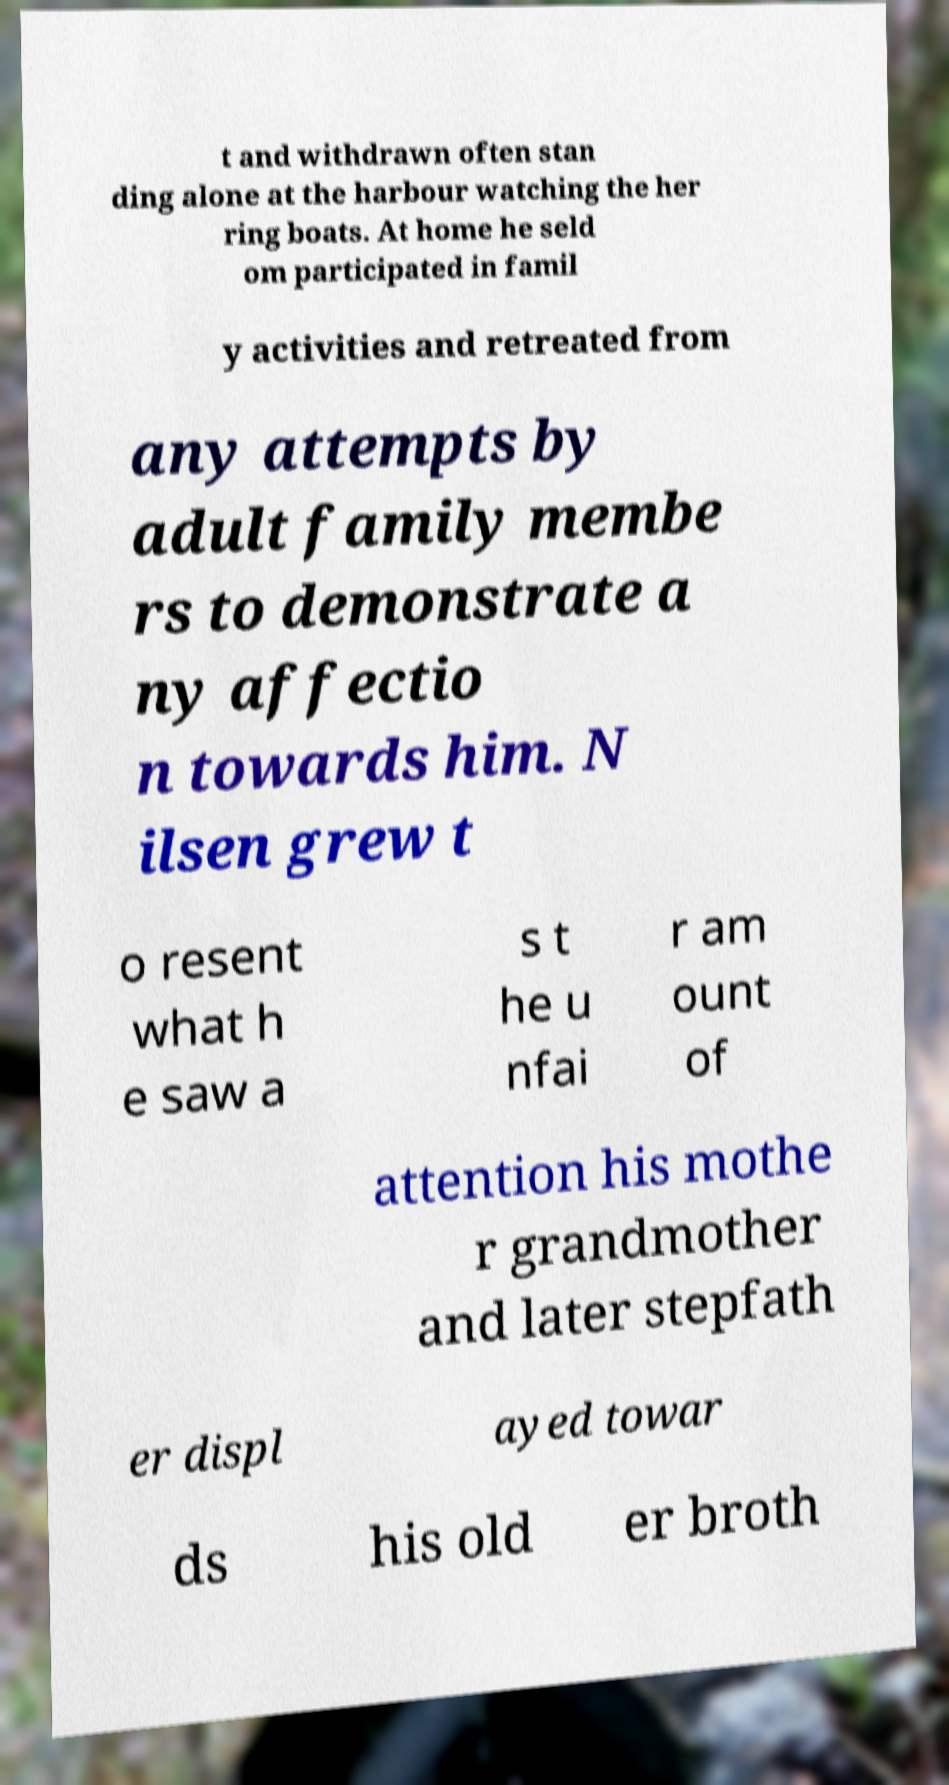Can you accurately transcribe the text from the provided image for me? t and withdrawn often stan ding alone at the harbour watching the her ring boats. At home he seld om participated in famil y activities and retreated from any attempts by adult family membe rs to demonstrate a ny affectio n towards him. N ilsen grew t o resent what h e saw a s t he u nfai r am ount of attention his mothe r grandmother and later stepfath er displ ayed towar ds his old er broth 